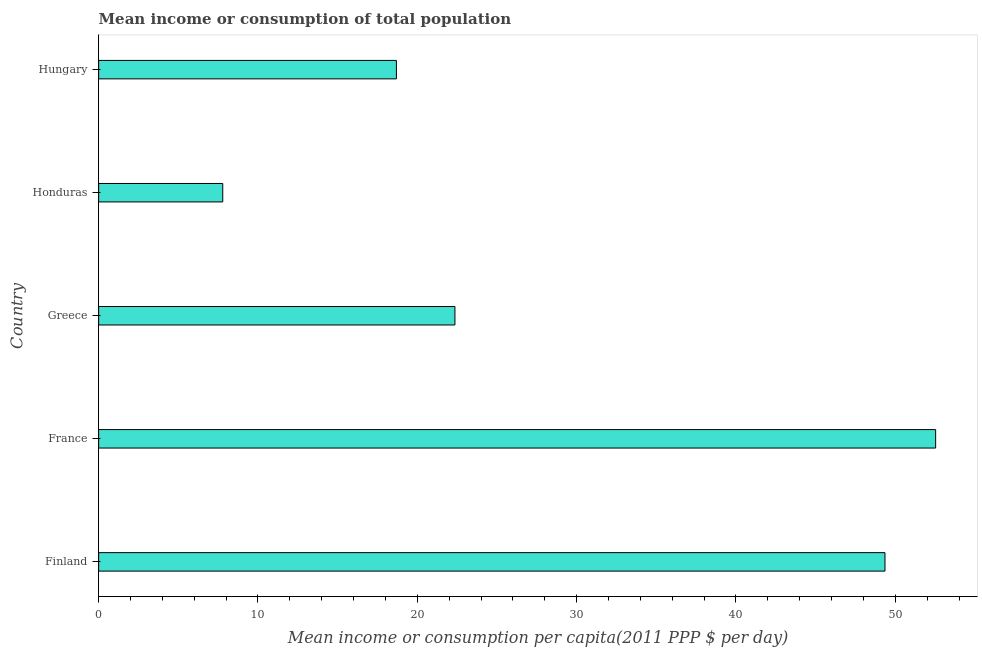What is the title of the graph?
Provide a short and direct response. Mean income or consumption of total population. What is the label or title of the X-axis?
Your response must be concise. Mean income or consumption per capita(2011 PPP $ per day). What is the label or title of the Y-axis?
Give a very brief answer. Country. What is the mean income or consumption in Finland?
Keep it short and to the point. 49.35. Across all countries, what is the maximum mean income or consumption?
Provide a succinct answer. 52.53. Across all countries, what is the minimum mean income or consumption?
Provide a succinct answer. 7.79. In which country was the mean income or consumption maximum?
Your answer should be compact. France. In which country was the mean income or consumption minimum?
Offer a very short reply. Honduras. What is the sum of the mean income or consumption?
Your answer should be very brief. 150.72. What is the difference between the mean income or consumption in France and Greece?
Your response must be concise. 30.17. What is the average mean income or consumption per country?
Give a very brief answer. 30.14. What is the median mean income or consumption?
Provide a short and direct response. 22.36. What is the ratio of the mean income or consumption in Greece to that in Honduras?
Offer a very short reply. 2.87. Is the mean income or consumption in Greece less than that in Hungary?
Provide a succinct answer. No. What is the difference between the highest and the second highest mean income or consumption?
Offer a terse response. 3.18. What is the difference between the highest and the lowest mean income or consumption?
Provide a short and direct response. 44.74. In how many countries, is the mean income or consumption greater than the average mean income or consumption taken over all countries?
Keep it short and to the point. 2. How many bars are there?
Keep it short and to the point. 5. Are the values on the major ticks of X-axis written in scientific E-notation?
Your answer should be very brief. No. What is the Mean income or consumption per capita(2011 PPP $ per day) of Finland?
Provide a succinct answer. 49.35. What is the Mean income or consumption per capita(2011 PPP $ per day) of France?
Provide a short and direct response. 52.53. What is the Mean income or consumption per capita(2011 PPP $ per day) in Greece?
Your answer should be compact. 22.36. What is the Mean income or consumption per capita(2011 PPP $ per day) in Honduras?
Provide a succinct answer. 7.79. What is the Mean income or consumption per capita(2011 PPP $ per day) of Hungary?
Ensure brevity in your answer.  18.69. What is the difference between the Mean income or consumption per capita(2011 PPP $ per day) in Finland and France?
Your answer should be very brief. -3.18. What is the difference between the Mean income or consumption per capita(2011 PPP $ per day) in Finland and Greece?
Make the answer very short. 26.99. What is the difference between the Mean income or consumption per capita(2011 PPP $ per day) in Finland and Honduras?
Ensure brevity in your answer.  41.56. What is the difference between the Mean income or consumption per capita(2011 PPP $ per day) in Finland and Hungary?
Make the answer very short. 30.66. What is the difference between the Mean income or consumption per capita(2011 PPP $ per day) in France and Greece?
Provide a succinct answer. 30.17. What is the difference between the Mean income or consumption per capita(2011 PPP $ per day) in France and Honduras?
Ensure brevity in your answer.  44.74. What is the difference between the Mean income or consumption per capita(2011 PPP $ per day) in France and Hungary?
Keep it short and to the point. 33.84. What is the difference between the Mean income or consumption per capita(2011 PPP $ per day) in Greece and Honduras?
Provide a succinct answer. 14.57. What is the difference between the Mean income or consumption per capita(2011 PPP $ per day) in Greece and Hungary?
Offer a terse response. 3.67. What is the difference between the Mean income or consumption per capita(2011 PPP $ per day) in Honduras and Hungary?
Your response must be concise. -10.9. What is the ratio of the Mean income or consumption per capita(2011 PPP $ per day) in Finland to that in France?
Keep it short and to the point. 0.94. What is the ratio of the Mean income or consumption per capita(2011 PPP $ per day) in Finland to that in Greece?
Ensure brevity in your answer.  2.21. What is the ratio of the Mean income or consumption per capita(2011 PPP $ per day) in Finland to that in Honduras?
Ensure brevity in your answer.  6.34. What is the ratio of the Mean income or consumption per capita(2011 PPP $ per day) in Finland to that in Hungary?
Give a very brief answer. 2.64. What is the ratio of the Mean income or consumption per capita(2011 PPP $ per day) in France to that in Greece?
Your answer should be compact. 2.35. What is the ratio of the Mean income or consumption per capita(2011 PPP $ per day) in France to that in Honduras?
Give a very brief answer. 6.74. What is the ratio of the Mean income or consumption per capita(2011 PPP $ per day) in France to that in Hungary?
Keep it short and to the point. 2.81. What is the ratio of the Mean income or consumption per capita(2011 PPP $ per day) in Greece to that in Honduras?
Your answer should be compact. 2.87. What is the ratio of the Mean income or consumption per capita(2011 PPP $ per day) in Greece to that in Hungary?
Provide a short and direct response. 1.2. What is the ratio of the Mean income or consumption per capita(2011 PPP $ per day) in Honduras to that in Hungary?
Provide a short and direct response. 0.42. 